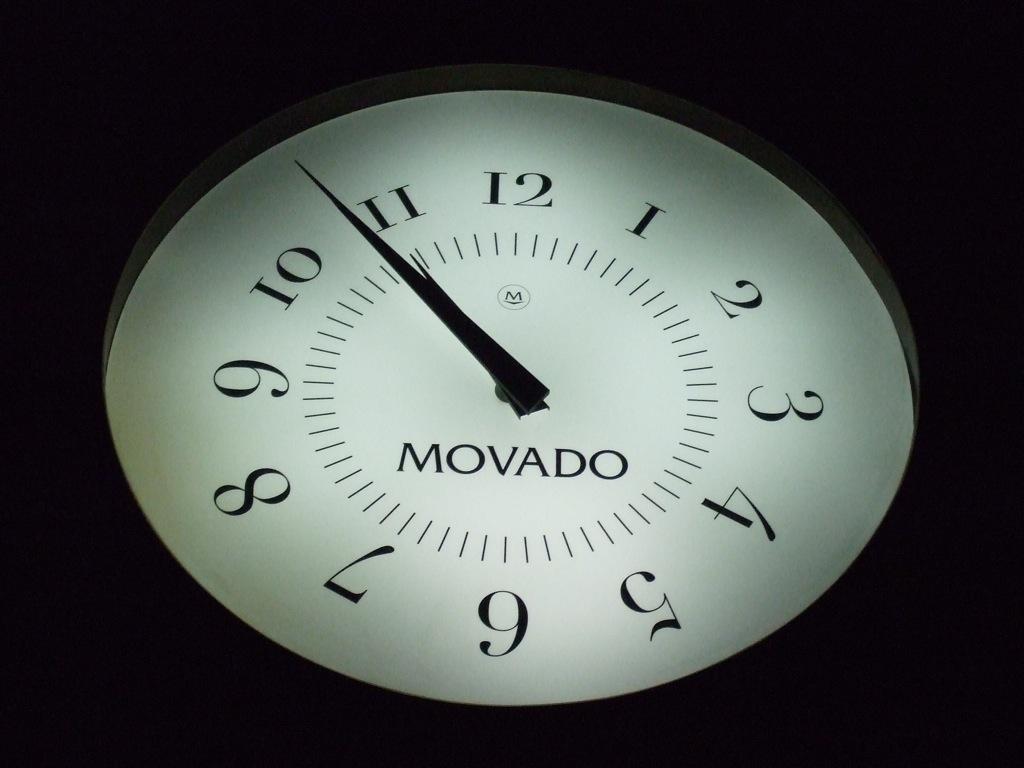What is the brand name of the clock?
Offer a terse response. Movado. What brand of clock is this?
Make the answer very short. Movado. 